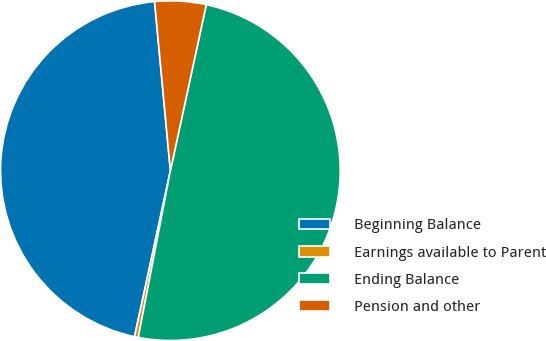Convert chart. <chart><loc_0><loc_0><loc_500><loc_500><pie_chart><fcel>Beginning Balance<fcel>Earnings available to Parent<fcel>Ending Balance<fcel>Pension and other<nl><fcel>45.13%<fcel>0.36%<fcel>49.64%<fcel>4.87%<nl></chart> 